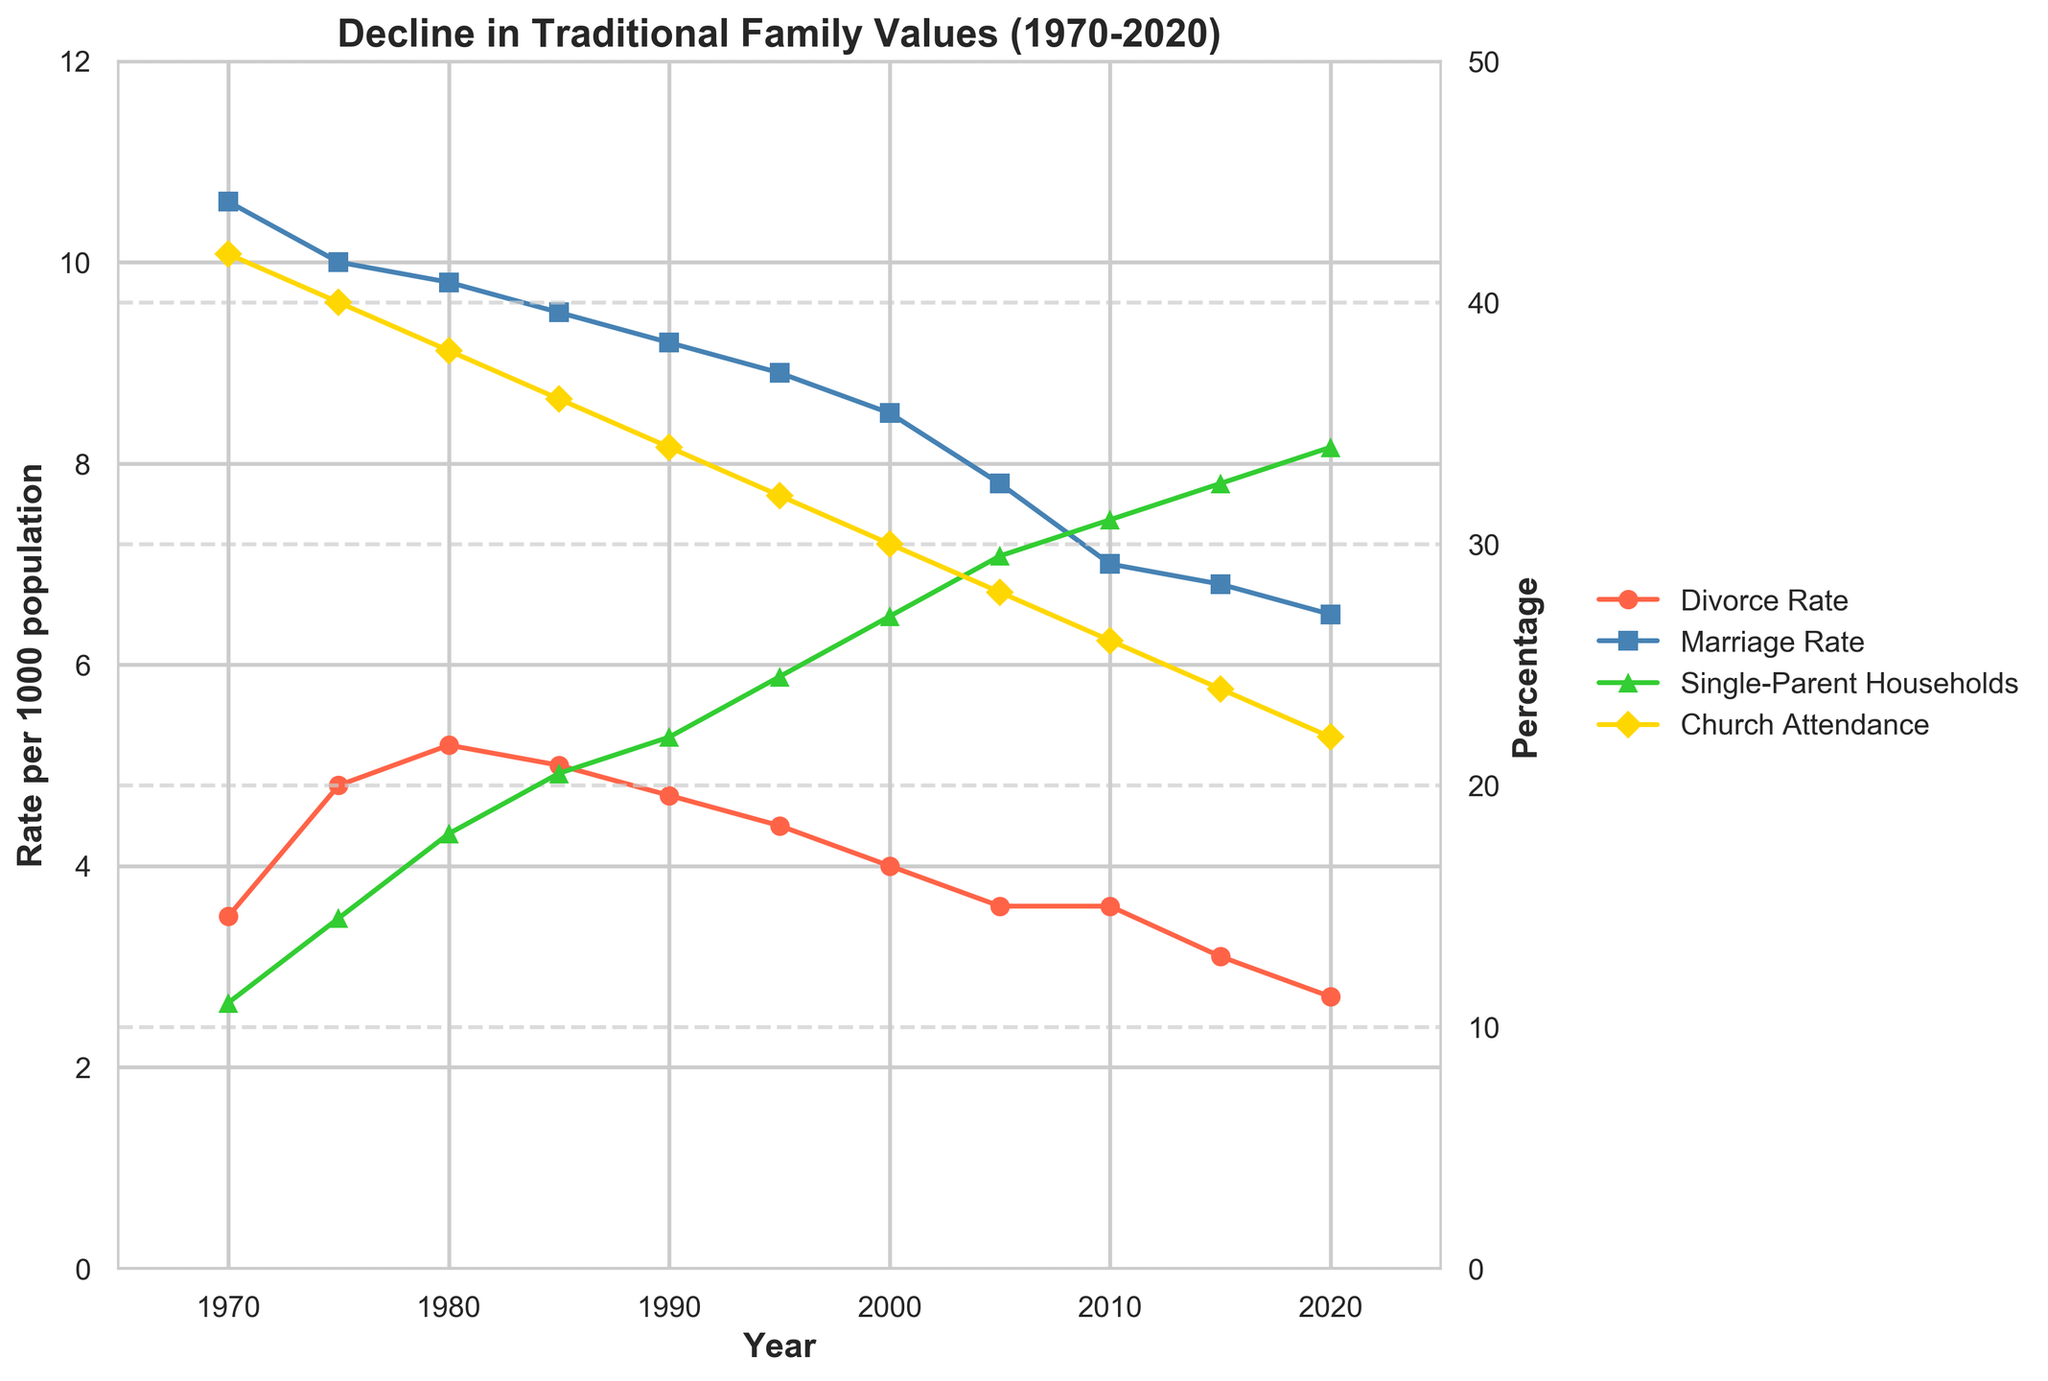What is the rate of church attendance in 2000? The rate of church attendance in the year 2000 is found by looking at the corresponding point on the church attendance line (colored in gold) for that year.
Answer: 30% What is the difference in the divorce rate between 1970 and 2020? To find the difference in the divorce rate, look at the divorce rate in 1970 (3.5 per 1000 population) and in 2020 (2.7 per 1000 population), then calculate the difference: 3.5 - 2.7.
Answer: 0.8 Which year had the highest percentage of single-parent households? The year with the highest percentage of single-parent households is determined by identifying the peak point on the single-parent households line (colored in green).
Answer: 2020 How does the marriage rate in 1995 compare to the marriage rate in 2015? To compare, look at the marriage rate in 1995 (8.9 per 1000 population) and in 2015 (6.8 per 1000 population).
Answer: The marriage rate in 1995 is higher than in 2015 What is the sum of the divorce rate and marriage rate in 1980? To calculate the sum, add the divorce rate in 1980 (5.2 per 1000 population) to the marriage rate in 1980 (9.8 per 1000 population): 5.2 + 9.8.
Answer: 15.0 What were the percentage points in the single-parent households from 1975 to 1985? To find the change, subtract the percentage of single-parent households in 1975 (14.5%) from the percentage in 1985 (20.5%): 20.5 - 14.5.
Answer: 6.0 percentage points What trend can be observed in church attendance from 1970 to 2020? The trend can be observed by following the church attendance line (colored in gold) from 1970 (42%) to 2020 (22%), which shows a decreasing pattern.
Answer: Church attendance decreases In which year is the gap between divorce rate and marriage rate the smallest? To determine the smallest gap, examine the differences between the divorce rate and the marriage rate for all years and identify the year with the smallest difference. The smallest gap is in 2000: 4.0 - 8.5 = -4.5.
Answer: 2000 What is the average percentage of single-parent households from 1970 to 2020? To calculate the average percentage, sum the percentages of single-parent households for all years and divide by the number of years (11): (11.0 + 14.5 + 18.0 + 20.5 + 22.0 + 24.5 + 27.0 + 29.5 + 31.0 + 32.5 + 34.0) / 11 = 24.5.
Answer: 24.5% How much did the church attendance percentage drop between 1990 and 2010? To find the drop, subtract the church attendance percentage in 2010 (26%) from the percentage in 1990 (34%): 34 - 26.
Answer: 8 percentage points 